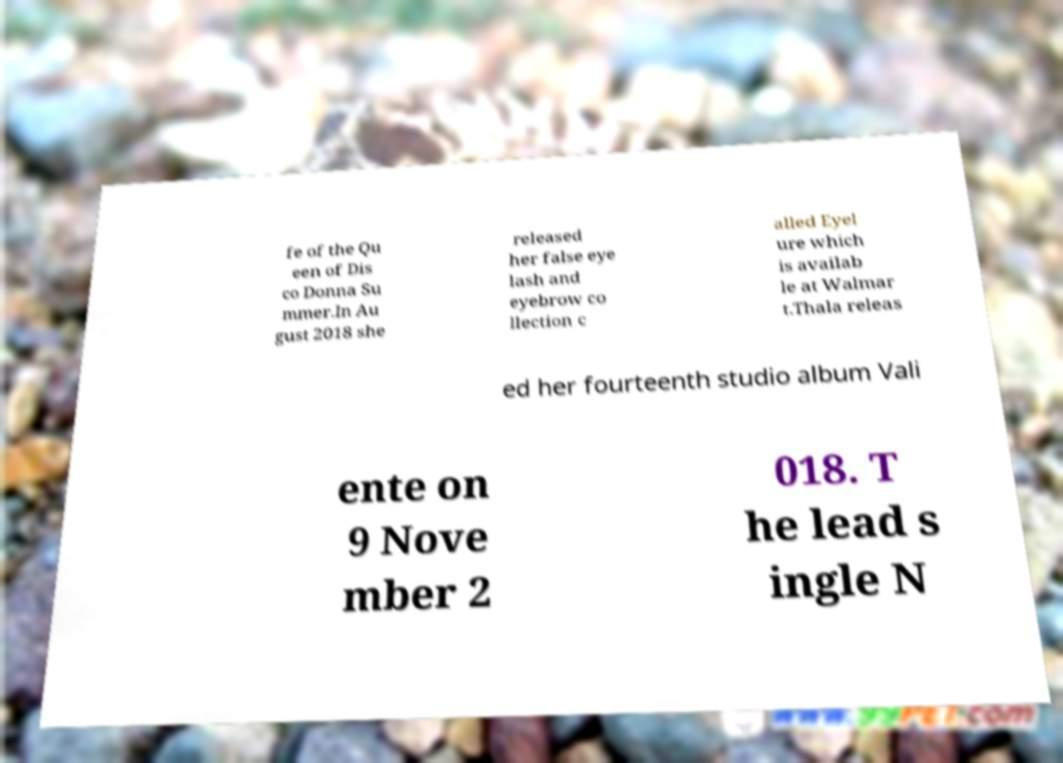For documentation purposes, I need the text within this image transcribed. Could you provide that? fe of the Qu een of Dis co Donna Su mmer.In Au gust 2018 she released her false eye lash and eyebrow co llection c alled Eyel ure which is availab le at Walmar t.Thala releas ed her fourteenth studio album Vali ente on 9 Nove mber 2 018. T he lead s ingle N 